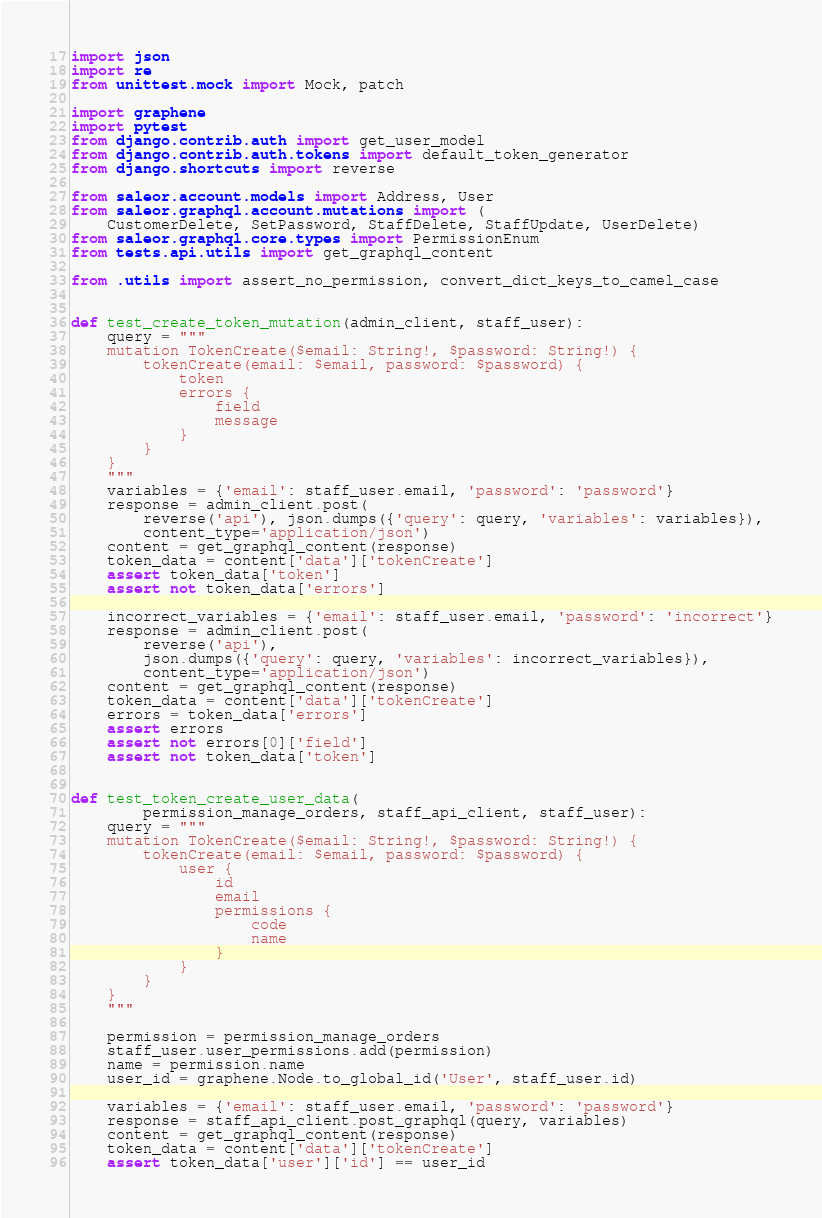Convert code to text. <code><loc_0><loc_0><loc_500><loc_500><_Python_>import json
import re
from unittest.mock import Mock, patch

import graphene
import pytest
from django.contrib.auth import get_user_model
from django.contrib.auth.tokens import default_token_generator
from django.shortcuts import reverse

from saleor.account.models import Address, User
from saleor.graphql.account.mutations import (
    CustomerDelete, SetPassword, StaffDelete, StaffUpdate, UserDelete)
from saleor.graphql.core.types import PermissionEnum
from tests.api.utils import get_graphql_content

from .utils import assert_no_permission, convert_dict_keys_to_camel_case


def test_create_token_mutation(admin_client, staff_user):
    query = """
    mutation TokenCreate($email: String!, $password: String!) {
        tokenCreate(email: $email, password: $password) {
            token
            errors {
                field
                message
            }
        }
    }
    """
    variables = {'email': staff_user.email, 'password': 'password'}
    response = admin_client.post(
        reverse('api'), json.dumps({'query': query, 'variables': variables}),
        content_type='application/json')
    content = get_graphql_content(response)
    token_data = content['data']['tokenCreate']
    assert token_data['token']
    assert not token_data['errors']

    incorrect_variables = {'email': staff_user.email, 'password': 'incorrect'}
    response = admin_client.post(
        reverse('api'),
        json.dumps({'query': query, 'variables': incorrect_variables}),
        content_type='application/json')
    content = get_graphql_content(response)
    token_data = content['data']['tokenCreate']
    errors = token_data['errors']
    assert errors
    assert not errors[0]['field']
    assert not token_data['token']


def test_token_create_user_data(
        permission_manage_orders, staff_api_client, staff_user):
    query = """
    mutation TokenCreate($email: String!, $password: String!) {
        tokenCreate(email: $email, password: $password) {
            user {
                id
                email
                permissions {
                    code
                    name
                }
            }
        }
    }
    """

    permission = permission_manage_orders
    staff_user.user_permissions.add(permission)
    name = permission.name
    user_id = graphene.Node.to_global_id('User', staff_user.id)

    variables = {'email': staff_user.email, 'password': 'password'}
    response = staff_api_client.post_graphql(query, variables)
    content = get_graphql_content(response)
    token_data = content['data']['tokenCreate']
    assert token_data['user']['id'] == user_id</code> 